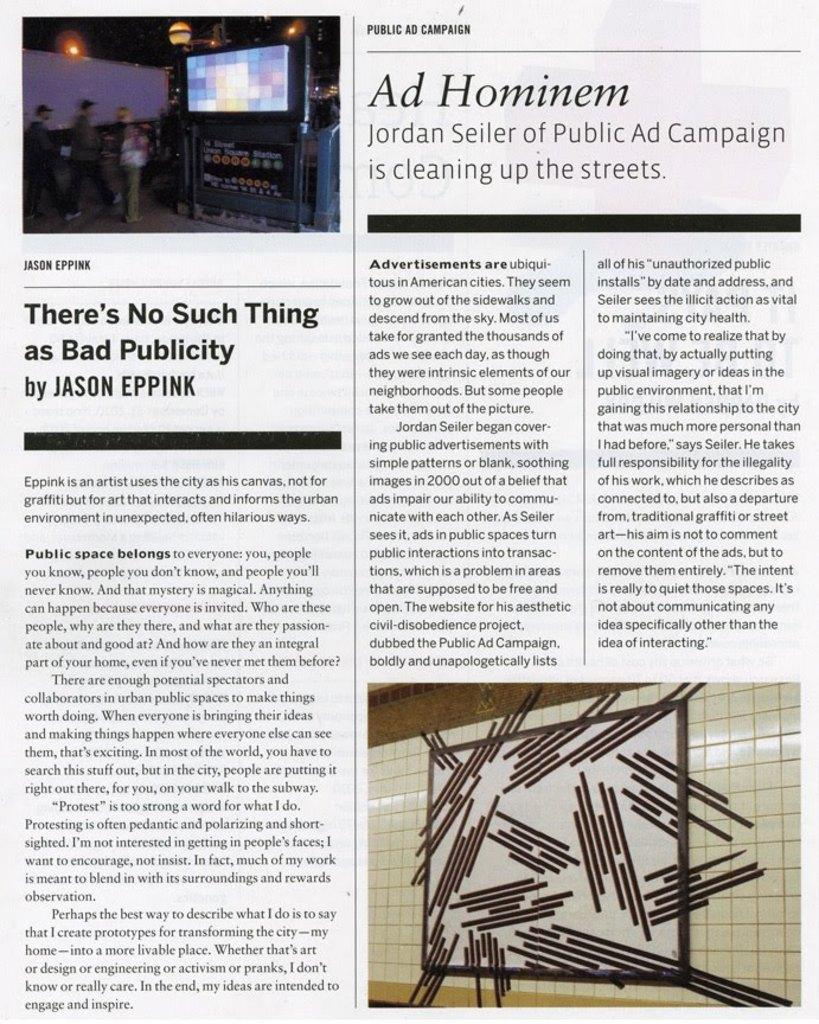What is present on the paper in the image? The paper contains text and a picture. What can be seen in the picture on the paper? The picture contains people and a screen. What is the primary purpose of the paper in the image? The paper is likely used for conveying information or presenting a message. What type of nose can be seen on the people in the picture? There is no nose visible in the image, as the picture only contains people and a screen. 